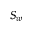Convert formula to latex. <formula><loc_0><loc_0><loc_500><loc_500>S _ { w }</formula> 